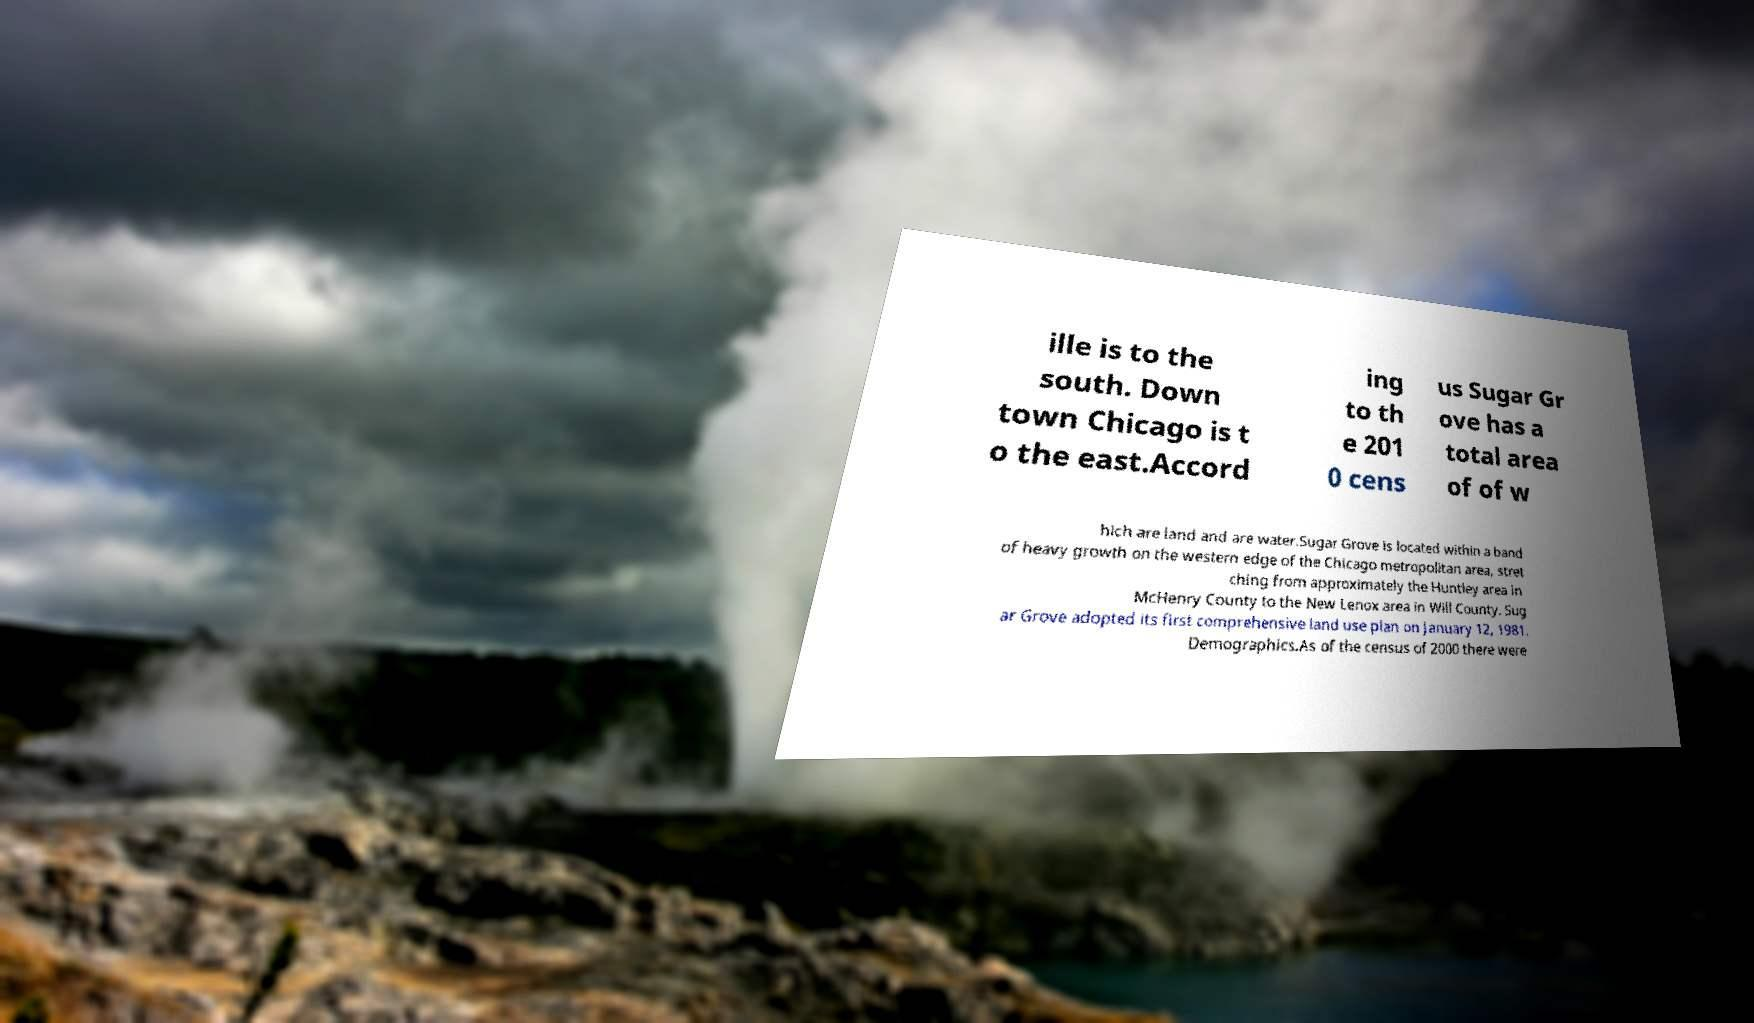Can you read and provide the text displayed in the image?This photo seems to have some interesting text. Can you extract and type it out for me? ille is to the south. Down town Chicago is t o the east.Accord ing to th e 201 0 cens us Sugar Gr ove has a total area of of w hich are land and are water.Sugar Grove is located within a band of heavy growth on the western edge of the Chicago metropolitan area, stret ching from approximately the Huntley area in McHenry County to the New Lenox area in Will County. Sug ar Grove adopted its first comprehensive land use plan on January 12, 1981. Demographics.As of the census of 2000 there were 